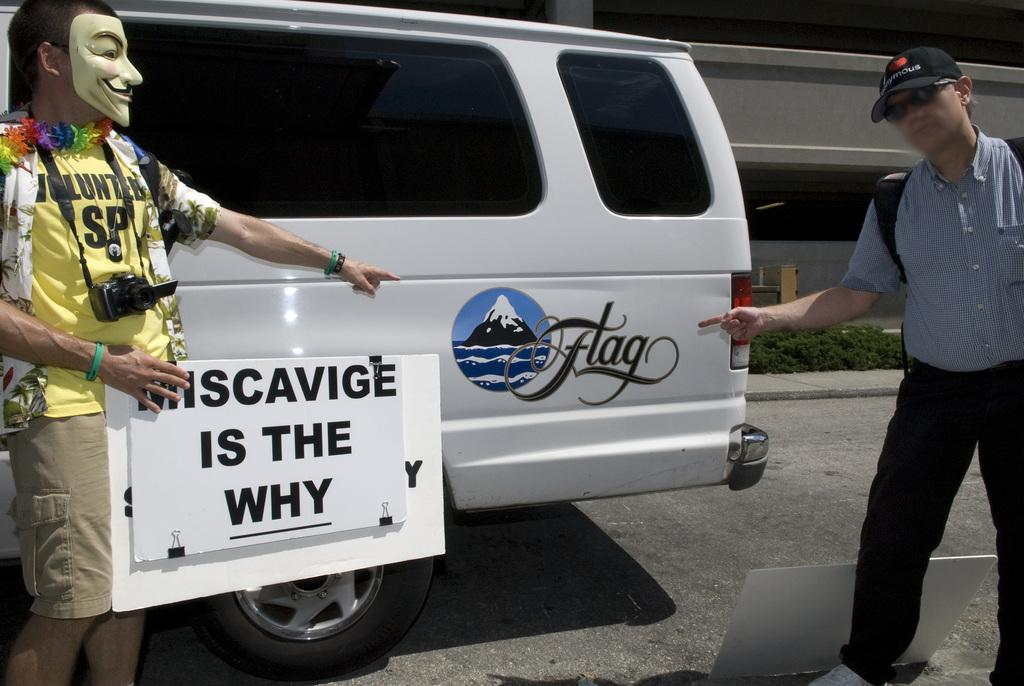<image>
Provide a brief description of the given image. A man holding a miscavige is the why sign pointing to another man. 